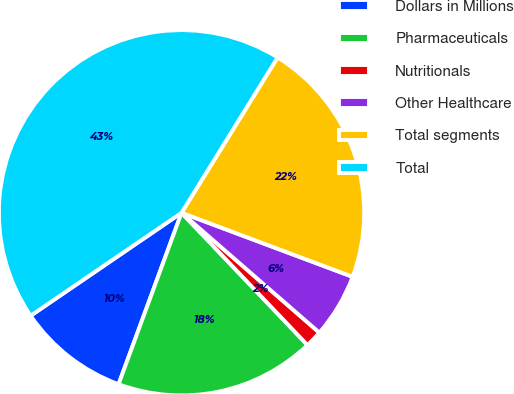Convert chart to OTSL. <chart><loc_0><loc_0><loc_500><loc_500><pie_chart><fcel>Dollars in Millions<fcel>Pharmaceuticals<fcel>Nutritionals<fcel>Other Healthcare<fcel>Total segments<fcel>Total<nl><fcel>9.87%<fcel>17.71%<fcel>1.5%<fcel>5.69%<fcel>21.89%<fcel>43.34%<nl></chart> 